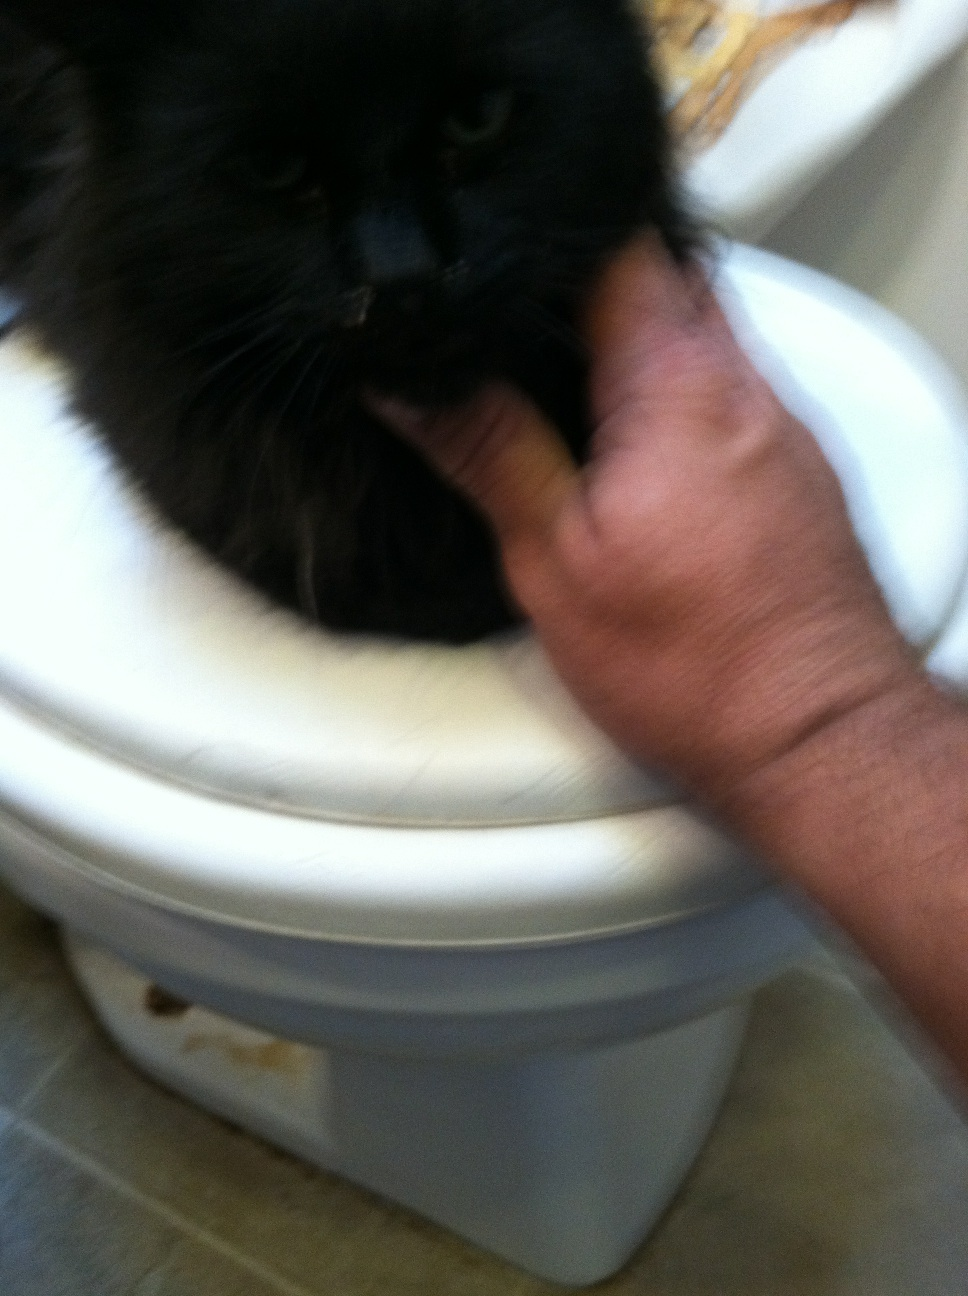Is there something that should be immediately addressed about the cat's well-being, judging from the picture? From the image, I can see that the cat's fur appears to be fairly well-kept, which is a good sign. However, the cat does seem to have some crustiness near the nose. This could be due to a variety of causes, such as a mild respiratory infection, allergies, or just normal grooming residue. If you're considering taking care of this stray, it would be a good idea to have a vet check it to ensure it’s healthy and to address any potential issues. 